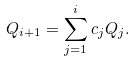<formula> <loc_0><loc_0><loc_500><loc_500>Q _ { i + 1 } = \sum _ { j = 1 } ^ { i } c _ { j } Q _ { j } .</formula> 